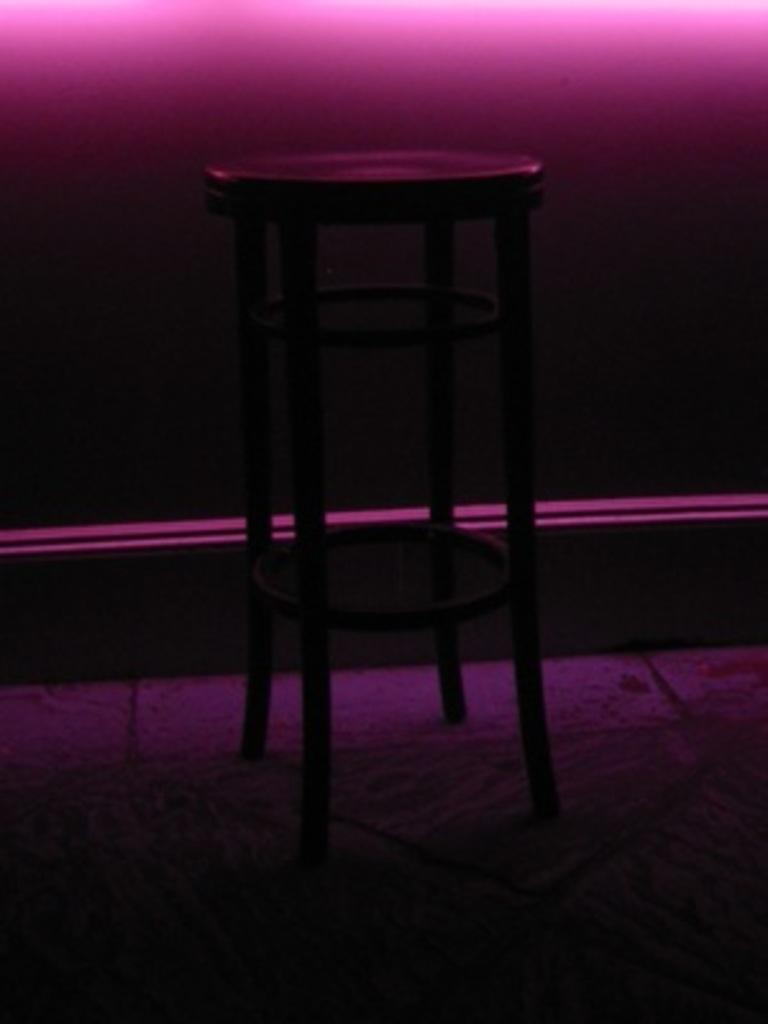What piece of furniture is placed on the floor in the image? There is a stool on the floor in the image. What type of lighting is present at the top of the image? There is a pink color light at the top of the image. What can be seen in the background of the image? There is a wall in the background of the image. Can you see a deer learning to play the piano in the image? No, there is no deer or piano present in the image. Where is the kitty playing with a ball of yarn in the image? There is no kitty or ball of yarn present in the image. 